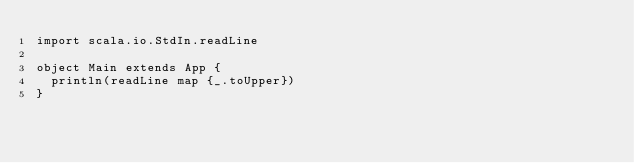Convert code to text. <code><loc_0><loc_0><loc_500><loc_500><_Scala_>import scala.io.StdIn.readLine

object Main extends App {
  println(readLine map {_.toUpper})
}</code> 